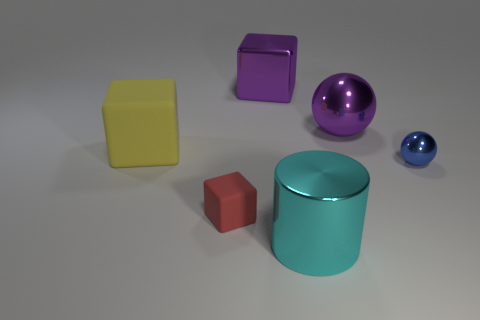Add 1 small yellow spheres. How many objects exist? 7 Subtract all spheres. How many objects are left? 4 Add 6 big metallic objects. How many big metallic objects exist? 9 Subtract 0 blue cylinders. How many objects are left? 6 Subtract all cyan metal spheres. Subtract all blue metallic objects. How many objects are left? 5 Add 5 blue metallic things. How many blue metallic things are left? 6 